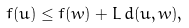Convert formula to latex. <formula><loc_0><loc_0><loc_500><loc_500>f ( u ) \leq f ( w ) + L \, d ( u , w ) ,</formula> 